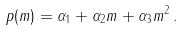Convert formula to latex. <formula><loc_0><loc_0><loc_500><loc_500>p ( m ) = \alpha _ { 1 } + \alpha _ { 2 } m + \alpha _ { 3 } m ^ { 2 } \, .</formula> 